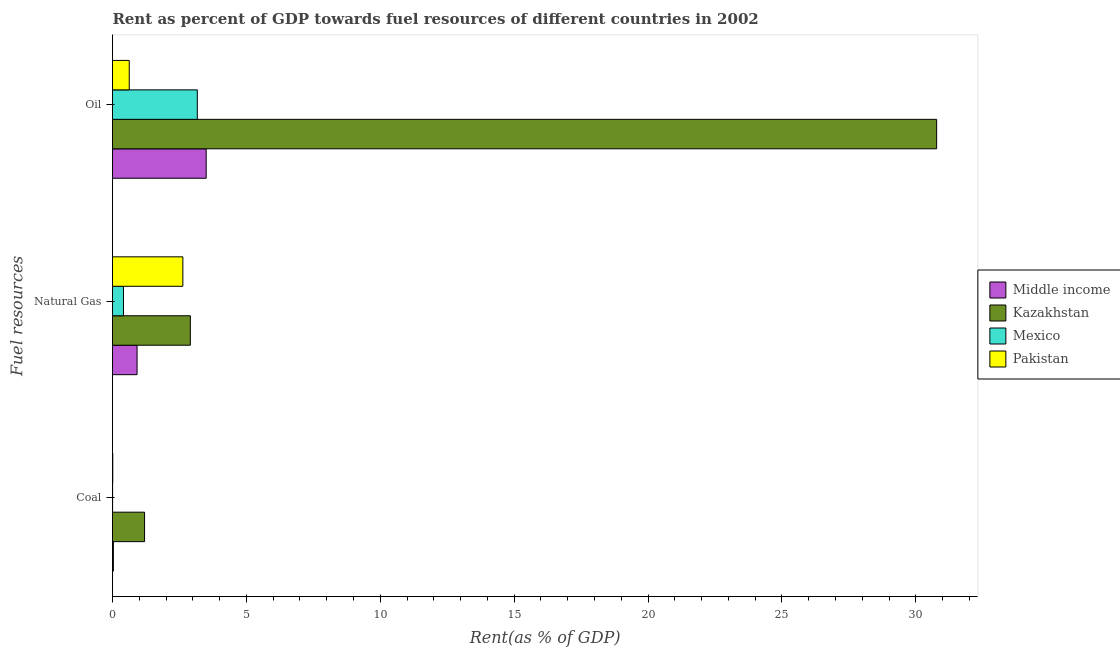How many different coloured bars are there?
Keep it short and to the point. 4. Are the number of bars per tick equal to the number of legend labels?
Offer a terse response. Yes. What is the label of the 1st group of bars from the top?
Your answer should be compact. Oil. What is the rent towards coal in Kazakhstan?
Provide a succinct answer. 1.2. Across all countries, what is the maximum rent towards natural gas?
Ensure brevity in your answer.  2.91. Across all countries, what is the minimum rent towards coal?
Ensure brevity in your answer.  0. In which country was the rent towards natural gas maximum?
Provide a short and direct response. Kazakhstan. What is the total rent towards oil in the graph?
Offer a very short reply. 38.07. What is the difference between the rent towards natural gas in Middle income and that in Kazakhstan?
Provide a short and direct response. -1.99. What is the difference between the rent towards coal in Middle income and the rent towards natural gas in Pakistan?
Provide a succinct answer. -2.59. What is the average rent towards coal per country?
Offer a terse response. 0.31. What is the difference between the rent towards coal and rent towards oil in Mexico?
Your response must be concise. -3.16. What is the ratio of the rent towards natural gas in Middle income to that in Mexico?
Your answer should be compact. 2.24. Is the rent towards coal in Kazakhstan less than that in Middle income?
Offer a terse response. No. What is the difference between the highest and the second highest rent towards oil?
Provide a short and direct response. 27.28. What is the difference between the highest and the lowest rent towards coal?
Provide a short and direct response. 1.19. What does the 3rd bar from the top in Natural Gas represents?
Make the answer very short. Kazakhstan. How many bars are there?
Give a very brief answer. 12. What is the difference between two consecutive major ticks on the X-axis?
Your answer should be very brief. 5. Are the values on the major ticks of X-axis written in scientific E-notation?
Offer a terse response. No. Does the graph contain any zero values?
Keep it short and to the point. No. Does the graph contain grids?
Give a very brief answer. No. Where does the legend appear in the graph?
Offer a very short reply. Center right. What is the title of the graph?
Provide a succinct answer. Rent as percent of GDP towards fuel resources of different countries in 2002. Does "Middle East & North Africa (developing only)" appear as one of the legend labels in the graph?
Your answer should be very brief. No. What is the label or title of the X-axis?
Make the answer very short. Rent(as % of GDP). What is the label or title of the Y-axis?
Provide a short and direct response. Fuel resources. What is the Rent(as % of GDP) in Middle income in Coal?
Give a very brief answer. 0.03. What is the Rent(as % of GDP) of Kazakhstan in Coal?
Provide a succinct answer. 1.2. What is the Rent(as % of GDP) in Mexico in Coal?
Your answer should be compact. 0. What is the Rent(as % of GDP) of Pakistan in Coal?
Offer a very short reply. 0.01. What is the Rent(as % of GDP) in Middle income in Natural Gas?
Your answer should be compact. 0.92. What is the Rent(as % of GDP) of Kazakhstan in Natural Gas?
Your answer should be very brief. 2.91. What is the Rent(as % of GDP) of Mexico in Natural Gas?
Your response must be concise. 0.41. What is the Rent(as % of GDP) of Pakistan in Natural Gas?
Offer a terse response. 2.63. What is the Rent(as % of GDP) of Middle income in Oil?
Offer a very short reply. 3.5. What is the Rent(as % of GDP) of Kazakhstan in Oil?
Ensure brevity in your answer.  30.78. What is the Rent(as % of GDP) in Mexico in Oil?
Give a very brief answer. 3.17. What is the Rent(as % of GDP) in Pakistan in Oil?
Offer a terse response. 0.63. Across all Fuel resources, what is the maximum Rent(as % of GDP) in Middle income?
Offer a terse response. 3.5. Across all Fuel resources, what is the maximum Rent(as % of GDP) in Kazakhstan?
Your answer should be very brief. 30.78. Across all Fuel resources, what is the maximum Rent(as % of GDP) of Mexico?
Your answer should be compact. 3.17. Across all Fuel resources, what is the maximum Rent(as % of GDP) in Pakistan?
Ensure brevity in your answer.  2.63. Across all Fuel resources, what is the minimum Rent(as % of GDP) of Middle income?
Offer a terse response. 0.03. Across all Fuel resources, what is the minimum Rent(as % of GDP) in Kazakhstan?
Provide a succinct answer. 1.2. Across all Fuel resources, what is the minimum Rent(as % of GDP) in Mexico?
Give a very brief answer. 0. Across all Fuel resources, what is the minimum Rent(as % of GDP) in Pakistan?
Your answer should be compact. 0.01. What is the total Rent(as % of GDP) in Middle income in the graph?
Ensure brevity in your answer.  4.45. What is the total Rent(as % of GDP) of Kazakhstan in the graph?
Offer a terse response. 34.88. What is the total Rent(as % of GDP) of Mexico in the graph?
Give a very brief answer. 3.58. What is the total Rent(as % of GDP) in Pakistan in the graph?
Your answer should be compact. 3.26. What is the difference between the Rent(as % of GDP) in Middle income in Coal and that in Natural Gas?
Make the answer very short. -0.88. What is the difference between the Rent(as % of GDP) of Kazakhstan in Coal and that in Natural Gas?
Make the answer very short. -1.71. What is the difference between the Rent(as % of GDP) in Mexico in Coal and that in Natural Gas?
Keep it short and to the point. -0.41. What is the difference between the Rent(as % of GDP) of Pakistan in Coal and that in Natural Gas?
Ensure brevity in your answer.  -2.62. What is the difference between the Rent(as % of GDP) of Middle income in Coal and that in Oil?
Give a very brief answer. -3.47. What is the difference between the Rent(as % of GDP) of Kazakhstan in Coal and that in Oil?
Your response must be concise. -29.58. What is the difference between the Rent(as % of GDP) of Mexico in Coal and that in Oil?
Provide a short and direct response. -3.16. What is the difference between the Rent(as % of GDP) in Pakistan in Coal and that in Oil?
Your answer should be compact. -0.62. What is the difference between the Rent(as % of GDP) in Middle income in Natural Gas and that in Oil?
Offer a terse response. -2.58. What is the difference between the Rent(as % of GDP) of Kazakhstan in Natural Gas and that in Oil?
Give a very brief answer. -27.87. What is the difference between the Rent(as % of GDP) of Mexico in Natural Gas and that in Oil?
Keep it short and to the point. -2.76. What is the difference between the Rent(as % of GDP) of Pakistan in Natural Gas and that in Oil?
Your answer should be compact. 2. What is the difference between the Rent(as % of GDP) in Middle income in Coal and the Rent(as % of GDP) in Kazakhstan in Natural Gas?
Give a very brief answer. -2.87. What is the difference between the Rent(as % of GDP) of Middle income in Coal and the Rent(as % of GDP) of Mexico in Natural Gas?
Offer a very short reply. -0.38. What is the difference between the Rent(as % of GDP) in Middle income in Coal and the Rent(as % of GDP) in Pakistan in Natural Gas?
Offer a very short reply. -2.59. What is the difference between the Rent(as % of GDP) in Kazakhstan in Coal and the Rent(as % of GDP) in Mexico in Natural Gas?
Your answer should be compact. 0.79. What is the difference between the Rent(as % of GDP) in Kazakhstan in Coal and the Rent(as % of GDP) in Pakistan in Natural Gas?
Your response must be concise. -1.43. What is the difference between the Rent(as % of GDP) in Mexico in Coal and the Rent(as % of GDP) in Pakistan in Natural Gas?
Your response must be concise. -2.62. What is the difference between the Rent(as % of GDP) of Middle income in Coal and the Rent(as % of GDP) of Kazakhstan in Oil?
Provide a short and direct response. -30.74. What is the difference between the Rent(as % of GDP) in Middle income in Coal and the Rent(as % of GDP) in Mexico in Oil?
Your response must be concise. -3.13. What is the difference between the Rent(as % of GDP) in Middle income in Coal and the Rent(as % of GDP) in Pakistan in Oil?
Your answer should be compact. -0.59. What is the difference between the Rent(as % of GDP) of Kazakhstan in Coal and the Rent(as % of GDP) of Mexico in Oil?
Ensure brevity in your answer.  -1.97. What is the difference between the Rent(as % of GDP) of Kazakhstan in Coal and the Rent(as % of GDP) of Pakistan in Oil?
Your answer should be very brief. 0.57. What is the difference between the Rent(as % of GDP) of Mexico in Coal and the Rent(as % of GDP) of Pakistan in Oil?
Keep it short and to the point. -0.62. What is the difference between the Rent(as % of GDP) of Middle income in Natural Gas and the Rent(as % of GDP) of Kazakhstan in Oil?
Make the answer very short. -29.86. What is the difference between the Rent(as % of GDP) of Middle income in Natural Gas and the Rent(as % of GDP) of Mexico in Oil?
Ensure brevity in your answer.  -2.25. What is the difference between the Rent(as % of GDP) of Middle income in Natural Gas and the Rent(as % of GDP) of Pakistan in Oil?
Provide a short and direct response. 0.29. What is the difference between the Rent(as % of GDP) of Kazakhstan in Natural Gas and the Rent(as % of GDP) of Mexico in Oil?
Offer a terse response. -0.26. What is the difference between the Rent(as % of GDP) in Kazakhstan in Natural Gas and the Rent(as % of GDP) in Pakistan in Oil?
Ensure brevity in your answer.  2.28. What is the difference between the Rent(as % of GDP) in Mexico in Natural Gas and the Rent(as % of GDP) in Pakistan in Oil?
Your response must be concise. -0.22. What is the average Rent(as % of GDP) of Middle income per Fuel resources?
Offer a very short reply. 1.48. What is the average Rent(as % of GDP) in Kazakhstan per Fuel resources?
Offer a terse response. 11.63. What is the average Rent(as % of GDP) in Mexico per Fuel resources?
Keep it short and to the point. 1.19. What is the average Rent(as % of GDP) of Pakistan per Fuel resources?
Your answer should be very brief. 1.09. What is the difference between the Rent(as % of GDP) in Middle income and Rent(as % of GDP) in Kazakhstan in Coal?
Give a very brief answer. -1.16. What is the difference between the Rent(as % of GDP) of Middle income and Rent(as % of GDP) of Mexico in Coal?
Provide a short and direct response. 0.03. What is the difference between the Rent(as % of GDP) of Middle income and Rent(as % of GDP) of Pakistan in Coal?
Your response must be concise. 0.02. What is the difference between the Rent(as % of GDP) in Kazakhstan and Rent(as % of GDP) in Mexico in Coal?
Your answer should be very brief. 1.19. What is the difference between the Rent(as % of GDP) in Kazakhstan and Rent(as % of GDP) in Pakistan in Coal?
Ensure brevity in your answer.  1.19. What is the difference between the Rent(as % of GDP) in Mexico and Rent(as % of GDP) in Pakistan in Coal?
Make the answer very short. -0.01. What is the difference between the Rent(as % of GDP) of Middle income and Rent(as % of GDP) of Kazakhstan in Natural Gas?
Offer a terse response. -1.99. What is the difference between the Rent(as % of GDP) of Middle income and Rent(as % of GDP) of Mexico in Natural Gas?
Your response must be concise. 0.51. What is the difference between the Rent(as % of GDP) in Middle income and Rent(as % of GDP) in Pakistan in Natural Gas?
Your answer should be very brief. -1.71. What is the difference between the Rent(as % of GDP) in Kazakhstan and Rent(as % of GDP) in Mexico in Natural Gas?
Offer a very short reply. 2.5. What is the difference between the Rent(as % of GDP) of Kazakhstan and Rent(as % of GDP) of Pakistan in Natural Gas?
Make the answer very short. 0.28. What is the difference between the Rent(as % of GDP) in Mexico and Rent(as % of GDP) in Pakistan in Natural Gas?
Provide a short and direct response. -2.22. What is the difference between the Rent(as % of GDP) of Middle income and Rent(as % of GDP) of Kazakhstan in Oil?
Ensure brevity in your answer.  -27.28. What is the difference between the Rent(as % of GDP) of Middle income and Rent(as % of GDP) of Mexico in Oil?
Provide a succinct answer. 0.33. What is the difference between the Rent(as % of GDP) of Middle income and Rent(as % of GDP) of Pakistan in Oil?
Keep it short and to the point. 2.87. What is the difference between the Rent(as % of GDP) in Kazakhstan and Rent(as % of GDP) in Mexico in Oil?
Offer a terse response. 27.61. What is the difference between the Rent(as % of GDP) in Kazakhstan and Rent(as % of GDP) in Pakistan in Oil?
Make the answer very short. 30.15. What is the difference between the Rent(as % of GDP) of Mexico and Rent(as % of GDP) of Pakistan in Oil?
Your answer should be very brief. 2.54. What is the ratio of the Rent(as % of GDP) in Middle income in Coal to that in Natural Gas?
Offer a terse response. 0.04. What is the ratio of the Rent(as % of GDP) in Kazakhstan in Coal to that in Natural Gas?
Ensure brevity in your answer.  0.41. What is the ratio of the Rent(as % of GDP) of Mexico in Coal to that in Natural Gas?
Your answer should be compact. 0.01. What is the ratio of the Rent(as % of GDP) of Pakistan in Coal to that in Natural Gas?
Provide a short and direct response. 0. What is the ratio of the Rent(as % of GDP) in Middle income in Coal to that in Oil?
Offer a terse response. 0.01. What is the ratio of the Rent(as % of GDP) of Kazakhstan in Coal to that in Oil?
Give a very brief answer. 0.04. What is the ratio of the Rent(as % of GDP) of Pakistan in Coal to that in Oil?
Your response must be concise. 0.02. What is the ratio of the Rent(as % of GDP) of Middle income in Natural Gas to that in Oil?
Provide a succinct answer. 0.26. What is the ratio of the Rent(as % of GDP) in Kazakhstan in Natural Gas to that in Oil?
Give a very brief answer. 0.09. What is the ratio of the Rent(as % of GDP) of Mexico in Natural Gas to that in Oil?
Your response must be concise. 0.13. What is the ratio of the Rent(as % of GDP) in Pakistan in Natural Gas to that in Oil?
Provide a succinct answer. 4.2. What is the difference between the highest and the second highest Rent(as % of GDP) of Middle income?
Offer a terse response. 2.58. What is the difference between the highest and the second highest Rent(as % of GDP) in Kazakhstan?
Give a very brief answer. 27.87. What is the difference between the highest and the second highest Rent(as % of GDP) of Mexico?
Offer a terse response. 2.76. What is the difference between the highest and the second highest Rent(as % of GDP) in Pakistan?
Offer a very short reply. 2. What is the difference between the highest and the lowest Rent(as % of GDP) of Middle income?
Offer a terse response. 3.47. What is the difference between the highest and the lowest Rent(as % of GDP) of Kazakhstan?
Provide a succinct answer. 29.58. What is the difference between the highest and the lowest Rent(as % of GDP) in Mexico?
Provide a succinct answer. 3.16. What is the difference between the highest and the lowest Rent(as % of GDP) of Pakistan?
Provide a short and direct response. 2.62. 